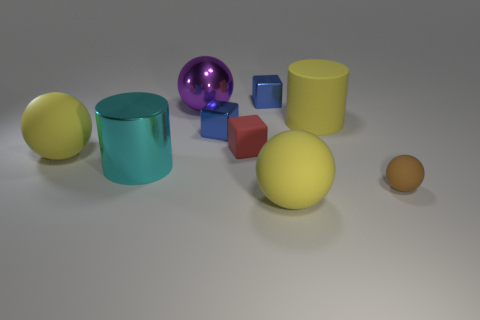Add 1 tiny red rubber objects. How many objects exist? 10 Subtract all purple spheres. How many blue blocks are left? 2 Subtract 2 balls. How many balls are left? 2 Subtract all brown balls. How many balls are left? 3 Subtract all rubber spheres. How many spheres are left? 1 Subtract all spheres. How many objects are left? 5 Subtract all red balls. Subtract all gray cylinders. How many balls are left? 4 Subtract all big brown matte blocks. Subtract all rubber objects. How many objects are left? 4 Add 5 blue cubes. How many blue cubes are left? 7 Add 1 big purple metallic things. How many big purple metallic things exist? 2 